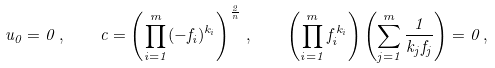Convert formula to latex. <formula><loc_0><loc_0><loc_500><loc_500>u _ { 0 } = 0 \, , \quad c = \left ( \prod _ { i = 1 } ^ { m } ( - f _ { i } ) ^ { k _ { i } } \right ) ^ { \frac { 2 } { n } } \, , \quad \left ( \prod _ { i = 1 } ^ { m } f _ { i } ^ { k _ { i } } \right ) \left ( \sum _ { j = 1 } ^ { m } \frac { 1 } { k _ { j } f _ { j } } \right ) = 0 \, ,</formula> 